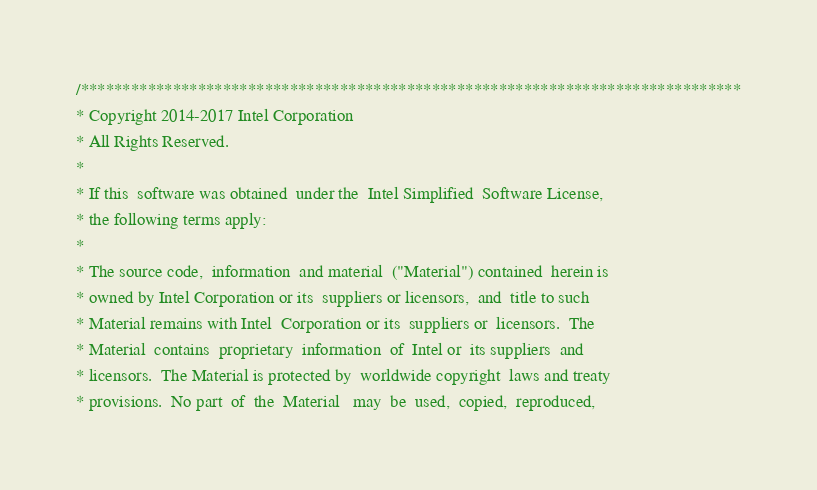Convert code to text. <code><loc_0><loc_0><loc_500><loc_500><_C_>/*******************************************************************************
* Copyright 2014-2017 Intel Corporation
* All Rights Reserved.
*
* If this  software was obtained  under the  Intel Simplified  Software License,
* the following terms apply:
*
* The source code,  information  and material  ("Material") contained  herein is
* owned by Intel Corporation or its  suppliers or licensors,  and  title to such
* Material remains with Intel  Corporation or its  suppliers or  licensors.  The
* Material  contains  proprietary  information  of  Intel or  its suppliers  and
* licensors.  The Material is protected by  worldwide copyright  laws and treaty
* provisions.  No part  of  the  Material   may  be  used,  copied,  reproduced,</code> 